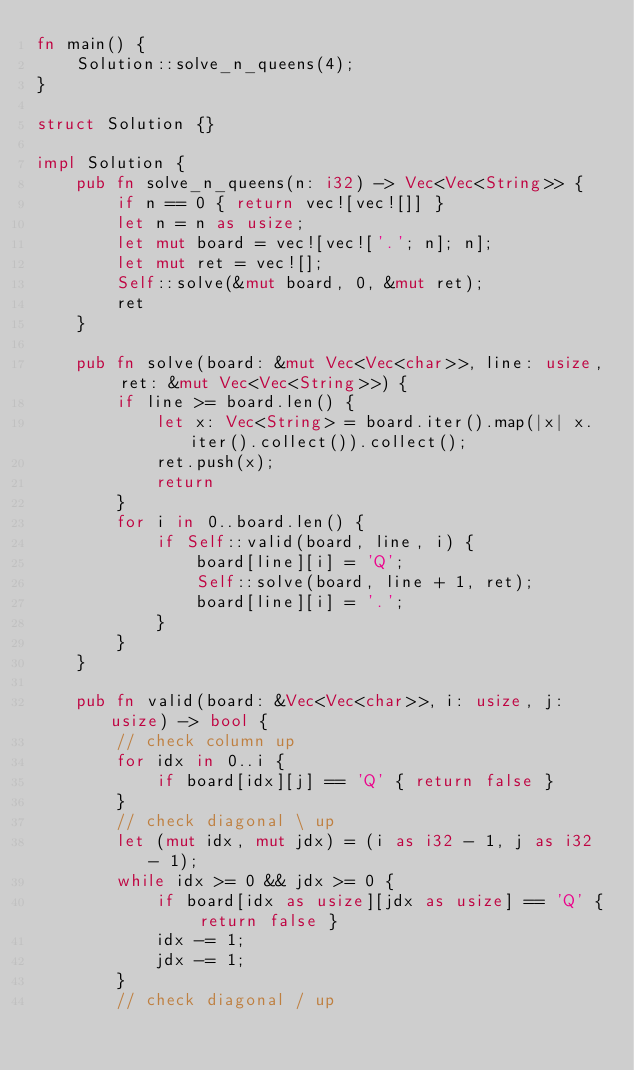<code> <loc_0><loc_0><loc_500><loc_500><_Rust_>fn main() {
    Solution::solve_n_queens(4);
}

struct Solution {}

impl Solution {
    pub fn solve_n_queens(n: i32) -> Vec<Vec<String>> {
        if n == 0 { return vec![vec![]] }
        let n = n as usize;
        let mut board = vec![vec!['.'; n]; n];
        let mut ret = vec![];
        Self::solve(&mut board, 0, &mut ret);
        ret
    }

    pub fn solve(board: &mut Vec<Vec<char>>, line: usize, ret: &mut Vec<Vec<String>>) {
        if line >= board.len() {
            let x: Vec<String> = board.iter().map(|x| x.iter().collect()).collect();
            ret.push(x);
            return
        }
        for i in 0..board.len() {
            if Self::valid(board, line, i) {
                board[line][i] = 'Q';
                Self::solve(board, line + 1, ret);
                board[line][i] = '.';
            }
        }
    }

    pub fn valid(board: &Vec<Vec<char>>, i: usize, j: usize) -> bool {
        // check column up
        for idx in 0..i {
            if board[idx][j] == 'Q' { return false }
        }
        // check diagonal \ up
        let (mut idx, mut jdx) = (i as i32 - 1, j as i32 - 1);
        while idx >= 0 && jdx >= 0 {
            if board[idx as usize][jdx as usize] == 'Q' { return false }
            idx -= 1;
            jdx -= 1;
        }
        // check diagonal / up</code> 